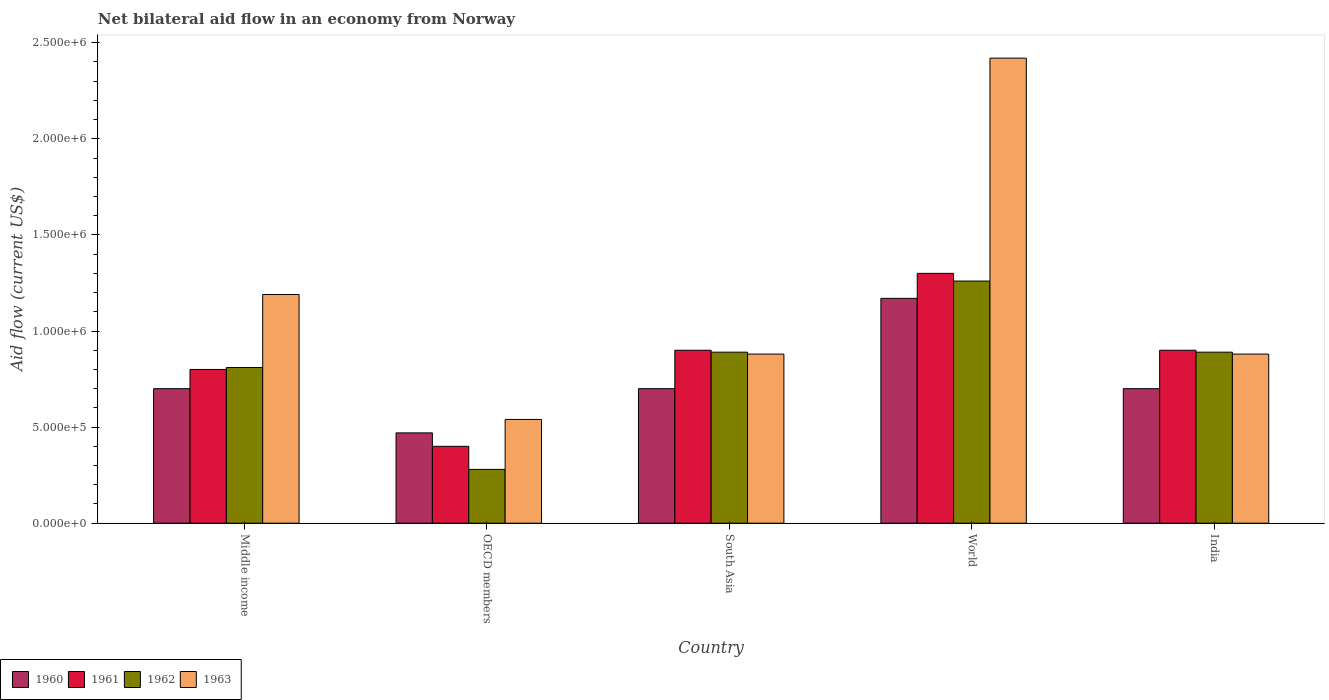How many groups of bars are there?
Provide a succinct answer. 5. How many bars are there on the 4th tick from the left?
Keep it short and to the point. 4. What is the label of the 1st group of bars from the left?
Your answer should be compact. Middle income. In how many cases, is the number of bars for a given country not equal to the number of legend labels?
Make the answer very short. 0. What is the net bilateral aid flow in 1961 in World?
Your answer should be compact. 1.30e+06. Across all countries, what is the maximum net bilateral aid flow in 1960?
Provide a succinct answer. 1.17e+06. Across all countries, what is the minimum net bilateral aid flow in 1962?
Your answer should be compact. 2.80e+05. In which country was the net bilateral aid flow in 1962 minimum?
Offer a terse response. OECD members. What is the total net bilateral aid flow in 1960 in the graph?
Make the answer very short. 3.74e+06. What is the difference between the net bilateral aid flow in 1962 in South Asia and that in World?
Ensure brevity in your answer.  -3.70e+05. What is the average net bilateral aid flow in 1961 per country?
Provide a short and direct response. 8.60e+05. What is the difference between the net bilateral aid flow of/in 1963 and net bilateral aid flow of/in 1962 in South Asia?
Provide a succinct answer. -10000. In how many countries, is the net bilateral aid flow in 1960 greater than 1200000 US$?
Give a very brief answer. 0. What is the ratio of the net bilateral aid flow in 1963 in India to that in Middle income?
Provide a short and direct response. 0.74. Is the difference between the net bilateral aid flow in 1963 in India and World greater than the difference between the net bilateral aid flow in 1962 in India and World?
Offer a terse response. No. What is the difference between the highest and the second highest net bilateral aid flow in 1961?
Keep it short and to the point. 4.00e+05. What is the difference between the highest and the lowest net bilateral aid flow in 1961?
Your answer should be very brief. 9.00e+05. In how many countries, is the net bilateral aid flow in 1963 greater than the average net bilateral aid flow in 1963 taken over all countries?
Keep it short and to the point. 2. What does the 1st bar from the left in OECD members represents?
Make the answer very short. 1960. What does the 1st bar from the right in India represents?
Provide a short and direct response. 1963. How many bars are there?
Provide a short and direct response. 20. Are all the bars in the graph horizontal?
Give a very brief answer. No. Are the values on the major ticks of Y-axis written in scientific E-notation?
Your response must be concise. Yes. Does the graph contain grids?
Give a very brief answer. No. Where does the legend appear in the graph?
Provide a short and direct response. Bottom left. What is the title of the graph?
Provide a succinct answer. Net bilateral aid flow in an economy from Norway. Does "1991" appear as one of the legend labels in the graph?
Ensure brevity in your answer.  No. What is the label or title of the X-axis?
Your answer should be compact. Country. What is the label or title of the Y-axis?
Give a very brief answer. Aid flow (current US$). What is the Aid flow (current US$) in 1961 in Middle income?
Give a very brief answer. 8.00e+05. What is the Aid flow (current US$) of 1962 in Middle income?
Your answer should be compact. 8.10e+05. What is the Aid flow (current US$) in 1963 in Middle income?
Provide a succinct answer. 1.19e+06. What is the Aid flow (current US$) in 1960 in OECD members?
Provide a succinct answer. 4.70e+05. What is the Aid flow (current US$) in 1962 in OECD members?
Offer a very short reply. 2.80e+05. What is the Aid flow (current US$) of 1963 in OECD members?
Your answer should be very brief. 5.40e+05. What is the Aid flow (current US$) in 1961 in South Asia?
Keep it short and to the point. 9.00e+05. What is the Aid flow (current US$) in 1962 in South Asia?
Make the answer very short. 8.90e+05. What is the Aid flow (current US$) of 1963 in South Asia?
Your answer should be compact. 8.80e+05. What is the Aid flow (current US$) of 1960 in World?
Provide a succinct answer. 1.17e+06. What is the Aid flow (current US$) in 1961 in World?
Keep it short and to the point. 1.30e+06. What is the Aid flow (current US$) of 1962 in World?
Provide a succinct answer. 1.26e+06. What is the Aid flow (current US$) in 1963 in World?
Your response must be concise. 2.42e+06. What is the Aid flow (current US$) in 1961 in India?
Your response must be concise. 9.00e+05. What is the Aid flow (current US$) in 1962 in India?
Keep it short and to the point. 8.90e+05. What is the Aid flow (current US$) of 1963 in India?
Keep it short and to the point. 8.80e+05. Across all countries, what is the maximum Aid flow (current US$) of 1960?
Your answer should be compact. 1.17e+06. Across all countries, what is the maximum Aid flow (current US$) in 1961?
Provide a succinct answer. 1.30e+06. Across all countries, what is the maximum Aid flow (current US$) of 1962?
Offer a terse response. 1.26e+06. Across all countries, what is the maximum Aid flow (current US$) in 1963?
Give a very brief answer. 2.42e+06. Across all countries, what is the minimum Aid flow (current US$) in 1962?
Your answer should be very brief. 2.80e+05. Across all countries, what is the minimum Aid flow (current US$) of 1963?
Provide a short and direct response. 5.40e+05. What is the total Aid flow (current US$) of 1960 in the graph?
Your answer should be very brief. 3.74e+06. What is the total Aid flow (current US$) of 1961 in the graph?
Your answer should be very brief. 4.30e+06. What is the total Aid flow (current US$) in 1962 in the graph?
Provide a succinct answer. 4.13e+06. What is the total Aid flow (current US$) of 1963 in the graph?
Your answer should be compact. 5.91e+06. What is the difference between the Aid flow (current US$) of 1960 in Middle income and that in OECD members?
Offer a very short reply. 2.30e+05. What is the difference between the Aid flow (current US$) in 1961 in Middle income and that in OECD members?
Give a very brief answer. 4.00e+05. What is the difference between the Aid flow (current US$) of 1962 in Middle income and that in OECD members?
Your answer should be compact. 5.30e+05. What is the difference between the Aid flow (current US$) of 1963 in Middle income and that in OECD members?
Ensure brevity in your answer.  6.50e+05. What is the difference between the Aid flow (current US$) in 1960 in Middle income and that in South Asia?
Your answer should be very brief. 0. What is the difference between the Aid flow (current US$) of 1960 in Middle income and that in World?
Offer a very short reply. -4.70e+05. What is the difference between the Aid flow (current US$) of 1961 in Middle income and that in World?
Your answer should be very brief. -5.00e+05. What is the difference between the Aid flow (current US$) in 1962 in Middle income and that in World?
Provide a succinct answer. -4.50e+05. What is the difference between the Aid flow (current US$) in 1963 in Middle income and that in World?
Your answer should be compact. -1.23e+06. What is the difference between the Aid flow (current US$) in 1962 in Middle income and that in India?
Your answer should be very brief. -8.00e+04. What is the difference between the Aid flow (current US$) in 1960 in OECD members and that in South Asia?
Ensure brevity in your answer.  -2.30e+05. What is the difference between the Aid flow (current US$) of 1961 in OECD members and that in South Asia?
Provide a short and direct response. -5.00e+05. What is the difference between the Aid flow (current US$) in 1962 in OECD members and that in South Asia?
Give a very brief answer. -6.10e+05. What is the difference between the Aid flow (current US$) of 1963 in OECD members and that in South Asia?
Provide a succinct answer. -3.40e+05. What is the difference between the Aid flow (current US$) in 1960 in OECD members and that in World?
Provide a succinct answer. -7.00e+05. What is the difference between the Aid flow (current US$) of 1961 in OECD members and that in World?
Make the answer very short. -9.00e+05. What is the difference between the Aid flow (current US$) in 1962 in OECD members and that in World?
Make the answer very short. -9.80e+05. What is the difference between the Aid flow (current US$) in 1963 in OECD members and that in World?
Offer a terse response. -1.88e+06. What is the difference between the Aid flow (current US$) of 1960 in OECD members and that in India?
Ensure brevity in your answer.  -2.30e+05. What is the difference between the Aid flow (current US$) in 1961 in OECD members and that in India?
Provide a short and direct response. -5.00e+05. What is the difference between the Aid flow (current US$) in 1962 in OECD members and that in India?
Your answer should be very brief. -6.10e+05. What is the difference between the Aid flow (current US$) in 1963 in OECD members and that in India?
Make the answer very short. -3.40e+05. What is the difference between the Aid flow (current US$) of 1960 in South Asia and that in World?
Offer a very short reply. -4.70e+05. What is the difference between the Aid flow (current US$) of 1961 in South Asia and that in World?
Make the answer very short. -4.00e+05. What is the difference between the Aid flow (current US$) in 1962 in South Asia and that in World?
Your answer should be compact. -3.70e+05. What is the difference between the Aid flow (current US$) of 1963 in South Asia and that in World?
Give a very brief answer. -1.54e+06. What is the difference between the Aid flow (current US$) in 1961 in South Asia and that in India?
Keep it short and to the point. 0. What is the difference between the Aid flow (current US$) in 1963 in South Asia and that in India?
Make the answer very short. 0. What is the difference between the Aid flow (current US$) in 1962 in World and that in India?
Offer a very short reply. 3.70e+05. What is the difference between the Aid flow (current US$) in 1963 in World and that in India?
Your answer should be compact. 1.54e+06. What is the difference between the Aid flow (current US$) in 1960 in Middle income and the Aid flow (current US$) in 1961 in OECD members?
Offer a terse response. 3.00e+05. What is the difference between the Aid flow (current US$) of 1960 in Middle income and the Aid flow (current US$) of 1962 in OECD members?
Give a very brief answer. 4.20e+05. What is the difference between the Aid flow (current US$) of 1960 in Middle income and the Aid flow (current US$) of 1963 in OECD members?
Your answer should be very brief. 1.60e+05. What is the difference between the Aid flow (current US$) of 1961 in Middle income and the Aid flow (current US$) of 1962 in OECD members?
Your answer should be very brief. 5.20e+05. What is the difference between the Aid flow (current US$) in 1961 in Middle income and the Aid flow (current US$) in 1963 in OECD members?
Your response must be concise. 2.60e+05. What is the difference between the Aid flow (current US$) in 1962 in Middle income and the Aid flow (current US$) in 1963 in OECD members?
Offer a very short reply. 2.70e+05. What is the difference between the Aid flow (current US$) of 1960 in Middle income and the Aid flow (current US$) of 1963 in South Asia?
Your answer should be very brief. -1.80e+05. What is the difference between the Aid flow (current US$) of 1961 in Middle income and the Aid flow (current US$) of 1962 in South Asia?
Offer a very short reply. -9.00e+04. What is the difference between the Aid flow (current US$) of 1961 in Middle income and the Aid flow (current US$) of 1963 in South Asia?
Provide a succinct answer. -8.00e+04. What is the difference between the Aid flow (current US$) of 1960 in Middle income and the Aid flow (current US$) of 1961 in World?
Provide a succinct answer. -6.00e+05. What is the difference between the Aid flow (current US$) in 1960 in Middle income and the Aid flow (current US$) in 1962 in World?
Keep it short and to the point. -5.60e+05. What is the difference between the Aid flow (current US$) of 1960 in Middle income and the Aid flow (current US$) of 1963 in World?
Give a very brief answer. -1.72e+06. What is the difference between the Aid flow (current US$) of 1961 in Middle income and the Aid flow (current US$) of 1962 in World?
Your response must be concise. -4.60e+05. What is the difference between the Aid flow (current US$) in 1961 in Middle income and the Aid flow (current US$) in 1963 in World?
Ensure brevity in your answer.  -1.62e+06. What is the difference between the Aid flow (current US$) of 1962 in Middle income and the Aid flow (current US$) of 1963 in World?
Keep it short and to the point. -1.61e+06. What is the difference between the Aid flow (current US$) of 1960 in Middle income and the Aid flow (current US$) of 1961 in India?
Offer a terse response. -2.00e+05. What is the difference between the Aid flow (current US$) of 1961 in Middle income and the Aid flow (current US$) of 1962 in India?
Offer a terse response. -9.00e+04. What is the difference between the Aid flow (current US$) in 1962 in Middle income and the Aid flow (current US$) in 1963 in India?
Offer a very short reply. -7.00e+04. What is the difference between the Aid flow (current US$) of 1960 in OECD members and the Aid flow (current US$) of 1961 in South Asia?
Ensure brevity in your answer.  -4.30e+05. What is the difference between the Aid flow (current US$) of 1960 in OECD members and the Aid flow (current US$) of 1962 in South Asia?
Offer a terse response. -4.20e+05. What is the difference between the Aid flow (current US$) of 1960 in OECD members and the Aid flow (current US$) of 1963 in South Asia?
Offer a very short reply. -4.10e+05. What is the difference between the Aid flow (current US$) of 1961 in OECD members and the Aid flow (current US$) of 1962 in South Asia?
Your answer should be very brief. -4.90e+05. What is the difference between the Aid flow (current US$) of 1961 in OECD members and the Aid flow (current US$) of 1963 in South Asia?
Provide a succinct answer. -4.80e+05. What is the difference between the Aid flow (current US$) of 1962 in OECD members and the Aid flow (current US$) of 1963 in South Asia?
Provide a short and direct response. -6.00e+05. What is the difference between the Aid flow (current US$) of 1960 in OECD members and the Aid flow (current US$) of 1961 in World?
Ensure brevity in your answer.  -8.30e+05. What is the difference between the Aid flow (current US$) in 1960 in OECD members and the Aid flow (current US$) in 1962 in World?
Your answer should be very brief. -7.90e+05. What is the difference between the Aid flow (current US$) of 1960 in OECD members and the Aid flow (current US$) of 1963 in World?
Make the answer very short. -1.95e+06. What is the difference between the Aid flow (current US$) of 1961 in OECD members and the Aid flow (current US$) of 1962 in World?
Keep it short and to the point. -8.60e+05. What is the difference between the Aid flow (current US$) of 1961 in OECD members and the Aid flow (current US$) of 1963 in World?
Your answer should be very brief. -2.02e+06. What is the difference between the Aid flow (current US$) in 1962 in OECD members and the Aid flow (current US$) in 1963 in World?
Your answer should be compact. -2.14e+06. What is the difference between the Aid flow (current US$) in 1960 in OECD members and the Aid flow (current US$) in 1961 in India?
Provide a succinct answer. -4.30e+05. What is the difference between the Aid flow (current US$) in 1960 in OECD members and the Aid flow (current US$) in 1962 in India?
Give a very brief answer. -4.20e+05. What is the difference between the Aid flow (current US$) of 1960 in OECD members and the Aid flow (current US$) of 1963 in India?
Keep it short and to the point. -4.10e+05. What is the difference between the Aid flow (current US$) in 1961 in OECD members and the Aid flow (current US$) in 1962 in India?
Keep it short and to the point. -4.90e+05. What is the difference between the Aid flow (current US$) of 1961 in OECD members and the Aid flow (current US$) of 1963 in India?
Make the answer very short. -4.80e+05. What is the difference between the Aid flow (current US$) of 1962 in OECD members and the Aid flow (current US$) of 1963 in India?
Offer a very short reply. -6.00e+05. What is the difference between the Aid flow (current US$) of 1960 in South Asia and the Aid flow (current US$) of 1961 in World?
Offer a terse response. -6.00e+05. What is the difference between the Aid flow (current US$) in 1960 in South Asia and the Aid flow (current US$) in 1962 in World?
Keep it short and to the point. -5.60e+05. What is the difference between the Aid flow (current US$) of 1960 in South Asia and the Aid flow (current US$) of 1963 in World?
Your answer should be very brief. -1.72e+06. What is the difference between the Aid flow (current US$) in 1961 in South Asia and the Aid flow (current US$) in 1962 in World?
Make the answer very short. -3.60e+05. What is the difference between the Aid flow (current US$) in 1961 in South Asia and the Aid flow (current US$) in 1963 in World?
Offer a very short reply. -1.52e+06. What is the difference between the Aid flow (current US$) in 1962 in South Asia and the Aid flow (current US$) in 1963 in World?
Provide a short and direct response. -1.53e+06. What is the difference between the Aid flow (current US$) in 1960 in South Asia and the Aid flow (current US$) in 1962 in India?
Make the answer very short. -1.90e+05. What is the difference between the Aid flow (current US$) in 1960 in South Asia and the Aid flow (current US$) in 1963 in India?
Keep it short and to the point. -1.80e+05. What is the difference between the Aid flow (current US$) of 1962 in South Asia and the Aid flow (current US$) of 1963 in India?
Ensure brevity in your answer.  10000. What is the difference between the Aid flow (current US$) of 1960 in World and the Aid flow (current US$) of 1961 in India?
Make the answer very short. 2.70e+05. What is the difference between the Aid flow (current US$) of 1961 in World and the Aid flow (current US$) of 1962 in India?
Make the answer very short. 4.10e+05. What is the difference between the Aid flow (current US$) in 1961 in World and the Aid flow (current US$) in 1963 in India?
Ensure brevity in your answer.  4.20e+05. What is the average Aid flow (current US$) of 1960 per country?
Ensure brevity in your answer.  7.48e+05. What is the average Aid flow (current US$) in 1961 per country?
Offer a terse response. 8.60e+05. What is the average Aid flow (current US$) of 1962 per country?
Give a very brief answer. 8.26e+05. What is the average Aid flow (current US$) in 1963 per country?
Provide a succinct answer. 1.18e+06. What is the difference between the Aid flow (current US$) of 1960 and Aid flow (current US$) of 1962 in Middle income?
Your response must be concise. -1.10e+05. What is the difference between the Aid flow (current US$) in 1960 and Aid flow (current US$) in 1963 in Middle income?
Make the answer very short. -4.90e+05. What is the difference between the Aid flow (current US$) in 1961 and Aid flow (current US$) in 1962 in Middle income?
Give a very brief answer. -10000. What is the difference between the Aid flow (current US$) in 1961 and Aid flow (current US$) in 1963 in Middle income?
Make the answer very short. -3.90e+05. What is the difference between the Aid flow (current US$) of 1962 and Aid flow (current US$) of 1963 in Middle income?
Your answer should be compact. -3.80e+05. What is the difference between the Aid flow (current US$) of 1961 and Aid flow (current US$) of 1963 in OECD members?
Offer a very short reply. -1.40e+05. What is the difference between the Aid flow (current US$) in 1962 and Aid flow (current US$) in 1963 in OECD members?
Your answer should be very brief. -2.60e+05. What is the difference between the Aid flow (current US$) in 1960 and Aid flow (current US$) in 1962 in South Asia?
Ensure brevity in your answer.  -1.90e+05. What is the difference between the Aid flow (current US$) in 1961 and Aid flow (current US$) in 1962 in South Asia?
Ensure brevity in your answer.  10000. What is the difference between the Aid flow (current US$) in 1960 and Aid flow (current US$) in 1961 in World?
Make the answer very short. -1.30e+05. What is the difference between the Aid flow (current US$) of 1960 and Aid flow (current US$) of 1963 in World?
Your response must be concise. -1.25e+06. What is the difference between the Aid flow (current US$) of 1961 and Aid flow (current US$) of 1963 in World?
Your response must be concise. -1.12e+06. What is the difference between the Aid flow (current US$) of 1962 and Aid flow (current US$) of 1963 in World?
Offer a very short reply. -1.16e+06. What is the difference between the Aid flow (current US$) in 1960 and Aid flow (current US$) in 1962 in India?
Provide a short and direct response. -1.90e+05. What is the difference between the Aid flow (current US$) of 1960 and Aid flow (current US$) of 1963 in India?
Your answer should be very brief. -1.80e+05. What is the difference between the Aid flow (current US$) of 1961 and Aid flow (current US$) of 1963 in India?
Ensure brevity in your answer.  2.00e+04. What is the difference between the Aid flow (current US$) of 1962 and Aid flow (current US$) of 1963 in India?
Your answer should be compact. 10000. What is the ratio of the Aid flow (current US$) of 1960 in Middle income to that in OECD members?
Your response must be concise. 1.49. What is the ratio of the Aid flow (current US$) in 1961 in Middle income to that in OECD members?
Provide a succinct answer. 2. What is the ratio of the Aid flow (current US$) in 1962 in Middle income to that in OECD members?
Your answer should be compact. 2.89. What is the ratio of the Aid flow (current US$) in 1963 in Middle income to that in OECD members?
Offer a terse response. 2.2. What is the ratio of the Aid flow (current US$) in 1962 in Middle income to that in South Asia?
Your answer should be very brief. 0.91. What is the ratio of the Aid flow (current US$) of 1963 in Middle income to that in South Asia?
Give a very brief answer. 1.35. What is the ratio of the Aid flow (current US$) in 1960 in Middle income to that in World?
Your answer should be very brief. 0.6. What is the ratio of the Aid flow (current US$) of 1961 in Middle income to that in World?
Your answer should be compact. 0.62. What is the ratio of the Aid flow (current US$) of 1962 in Middle income to that in World?
Your answer should be compact. 0.64. What is the ratio of the Aid flow (current US$) of 1963 in Middle income to that in World?
Provide a short and direct response. 0.49. What is the ratio of the Aid flow (current US$) of 1960 in Middle income to that in India?
Keep it short and to the point. 1. What is the ratio of the Aid flow (current US$) of 1962 in Middle income to that in India?
Offer a terse response. 0.91. What is the ratio of the Aid flow (current US$) of 1963 in Middle income to that in India?
Your answer should be compact. 1.35. What is the ratio of the Aid flow (current US$) of 1960 in OECD members to that in South Asia?
Your response must be concise. 0.67. What is the ratio of the Aid flow (current US$) in 1961 in OECD members to that in South Asia?
Your response must be concise. 0.44. What is the ratio of the Aid flow (current US$) of 1962 in OECD members to that in South Asia?
Offer a terse response. 0.31. What is the ratio of the Aid flow (current US$) in 1963 in OECD members to that in South Asia?
Ensure brevity in your answer.  0.61. What is the ratio of the Aid flow (current US$) in 1960 in OECD members to that in World?
Your answer should be very brief. 0.4. What is the ratio of the Aid flow (current US$) in 1961 in OECD members to that in World?
Your answer should be very brief. 0.31. What is the ratio of the Aid flow (current US$) of 1962 in OECD members to that in World?
Provide a succinct answer. 0.22. What is the ratio of the Aid flow (current US$) of 1963 in OECD members to that in World?
Your answer should be very brief. 0.22. What is the ratio of the Aid flow (current US$) in 1960 in OECD members to that in India?
Give a very brief answer. 0.67. What is the ratio of the Aid flow (current US$) in 1961 in OECD members to that in India?
Your answer should be compact. 0.44. What is the ratio of the Aid flow (current US$) of 1962 in OECD members to that in India?
Provide a short and direct response. 0.31. What is the ratio of the Aid flow (current US$) of 1963 in OECD members to that in India?
Offer a terse response. 0.61. What is the ratio of the Aid flow (current US$) in 1960 in South Asia to that in World?
Offer a terse response. 0.6. What is the ratio of the Aid flow (current US$) of 1961 in South Asia to that in World?
Ensure brevity in your answer.  0.69. What is the ratio of the Aid flow (current US$) of 1962 in South Asia to that in World?
Ensure brevity in your answer.  0.71. What is the ratio of the Aid flow (current US$) in 1963 in South Asia to that in World?
Your answer should be very brief. 0.36. What is the ratio of the Aid flow (current US$) in 1962 in South Asia to that in India?
Provide a short and direct response. 1. What is the ratio of the Aid flow (current US$) in 1960 in World to that in India?
Offer a very short reply. 1.67. What is the ratio of the Aid flow (current US$) of 1961 in World to that in India?
Keep it short and to the point. 1.44. What is the ratio of the Aid flow (current US$) in 1962 in World to that in India?
Your response must be concise. 1.42. What is the ratio of the Aid flow (current US$) in 1963 in World to that in India?
Keep it short and to the point. 2.75. What is the difference between the highest and the second highest Aid flow (current US$) of 1960?
Keep it short and to the point. 4.70e+05. What is the difference between the highest and the second highest Aid flow (current US$) in 1961?
Your response must be concise. 4.00e+05. What is the difference between the highest and the second highest Aid flow (current US$) in 1962?
Give a very brief answer. 3.70e+05. What is the difference between the highest and the second highest Aid flow (current US$) of 1963?
Make the answer very short. 1.23e+06. What is the difference between the highest and the lowest Aid flow (current US$) in 1962?
Your response must be concise. 9.80e+05. What is the difference between the highest and the lowest Aid flow (current US$) of 1963?
Provide a short and direct response. 1.88e+06. 